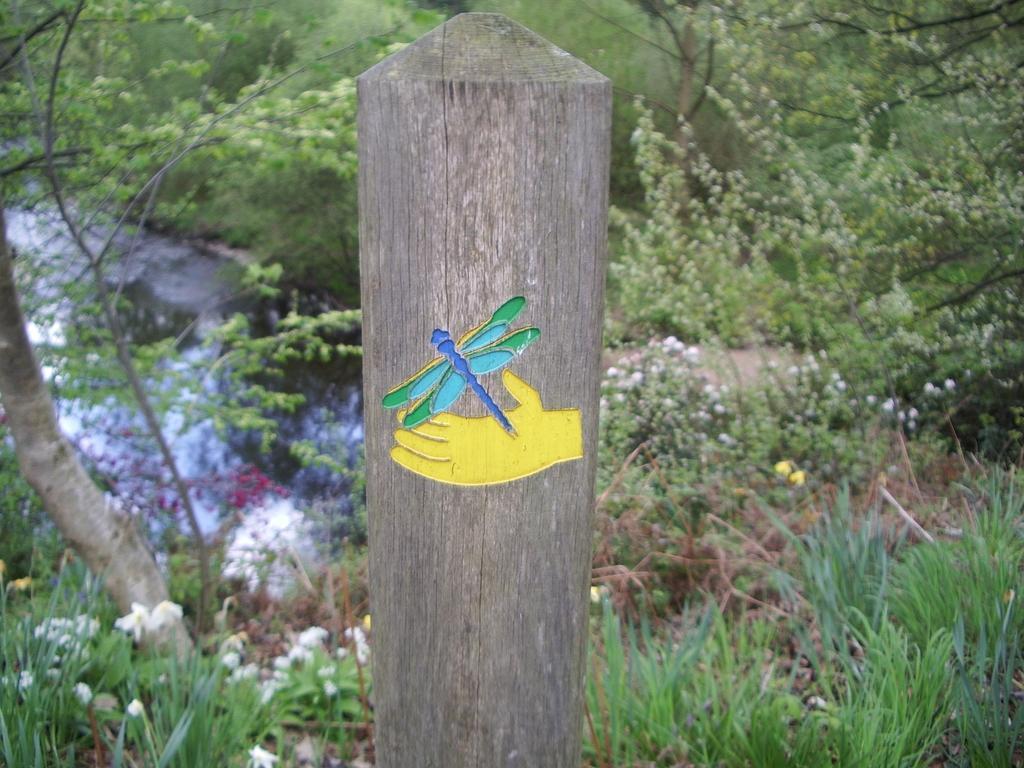Describe this image in one or two sentences. In front of the picture, we see a wooden pole on which an insect and the hand of a person is drawn or it might be the stickers. At the bottom of the picture, we see the grass and the plants. There are trees and water in the background. 